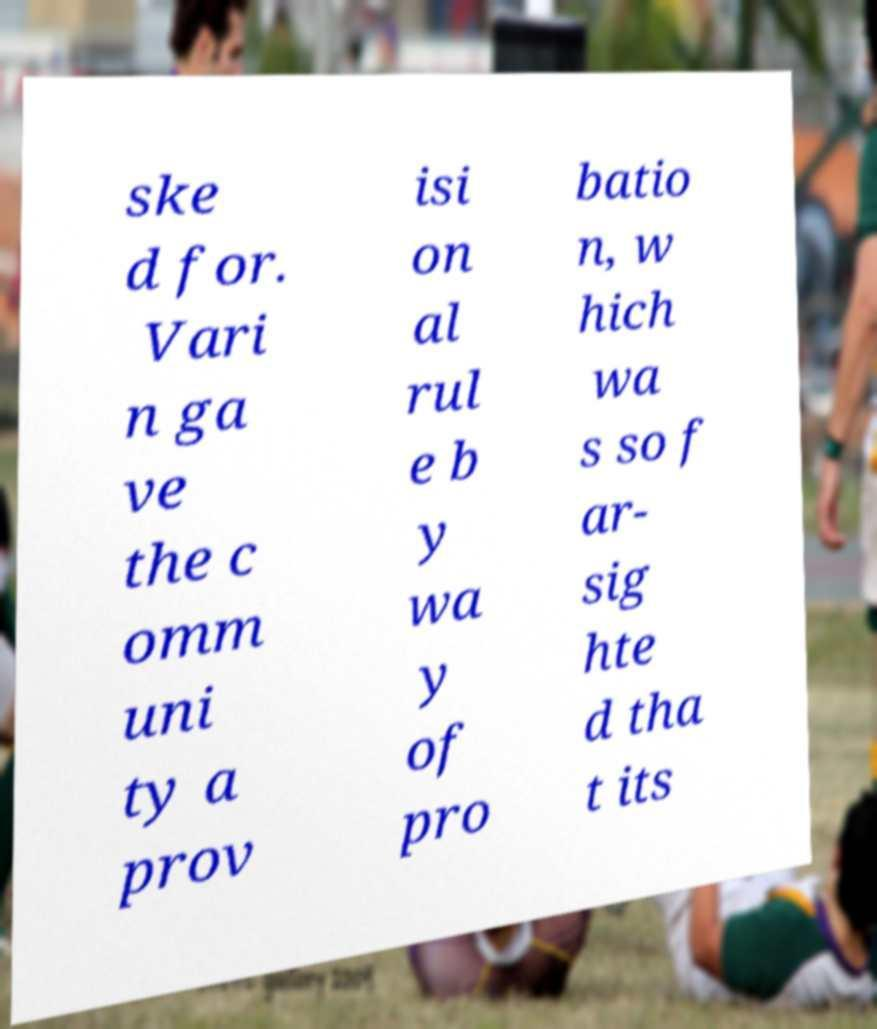What messages or text are displayed in this image? I need them in a readable, typed format. ske d for. Vari n ga ve the c omm uni ty a prov isi on al rul e b y wa y of pro batio n, w hich wa s so f ar- sig hte d tha t its 